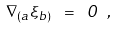Convert formula to latex. <formula><loc_0><loc_0><loc_500><loc_500>\nabla _ { ( a } \xi _ { b ) } \ = \ 0 \ ,</formula> 